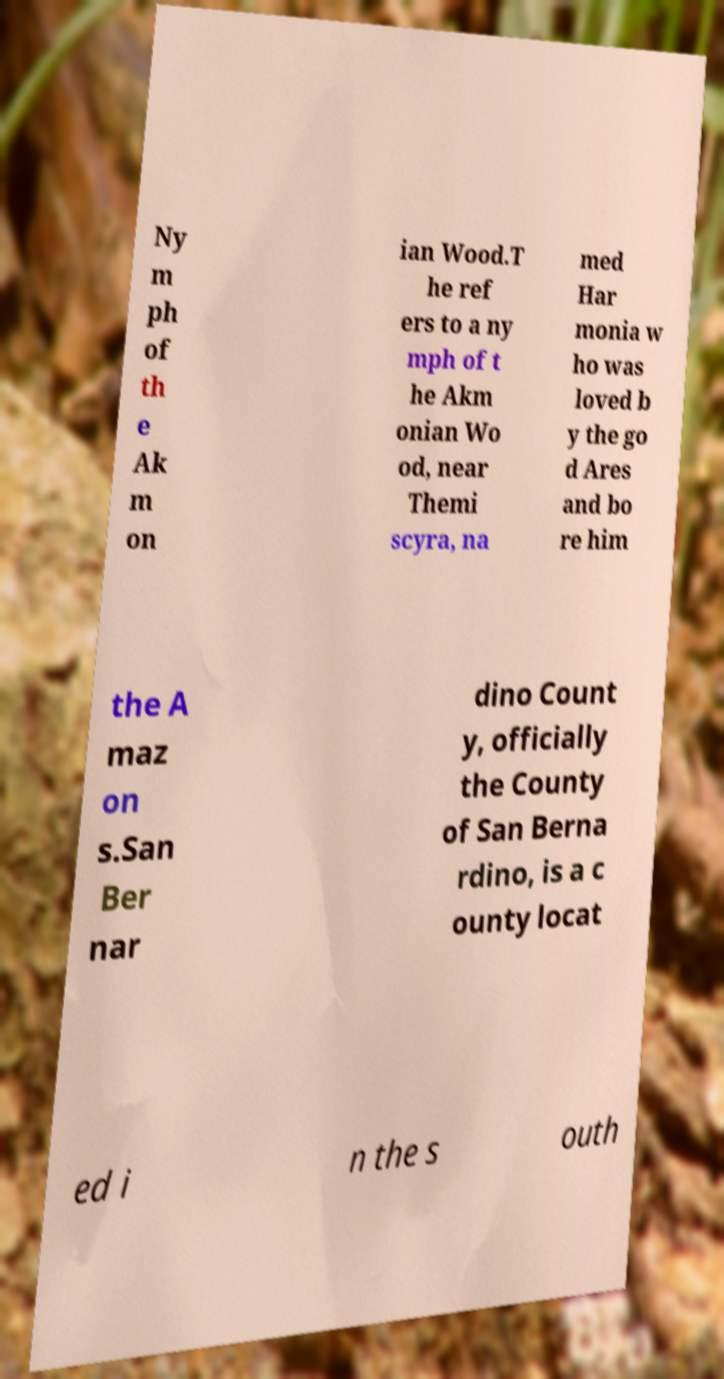Please read and relay the text visible in this image. What does it say? Ny m ph of th e Ak m on ian Wood.T he ref ers to a ny mph of t he Akm onian Wo od, near Themi scyra, na med Har monia w ho was loved b y the go d Ares and bo re him the A maz on s.San Ber nar dino Count y, officially the County of San Berna rdino, is a c ounty locat ed i n the s outh 